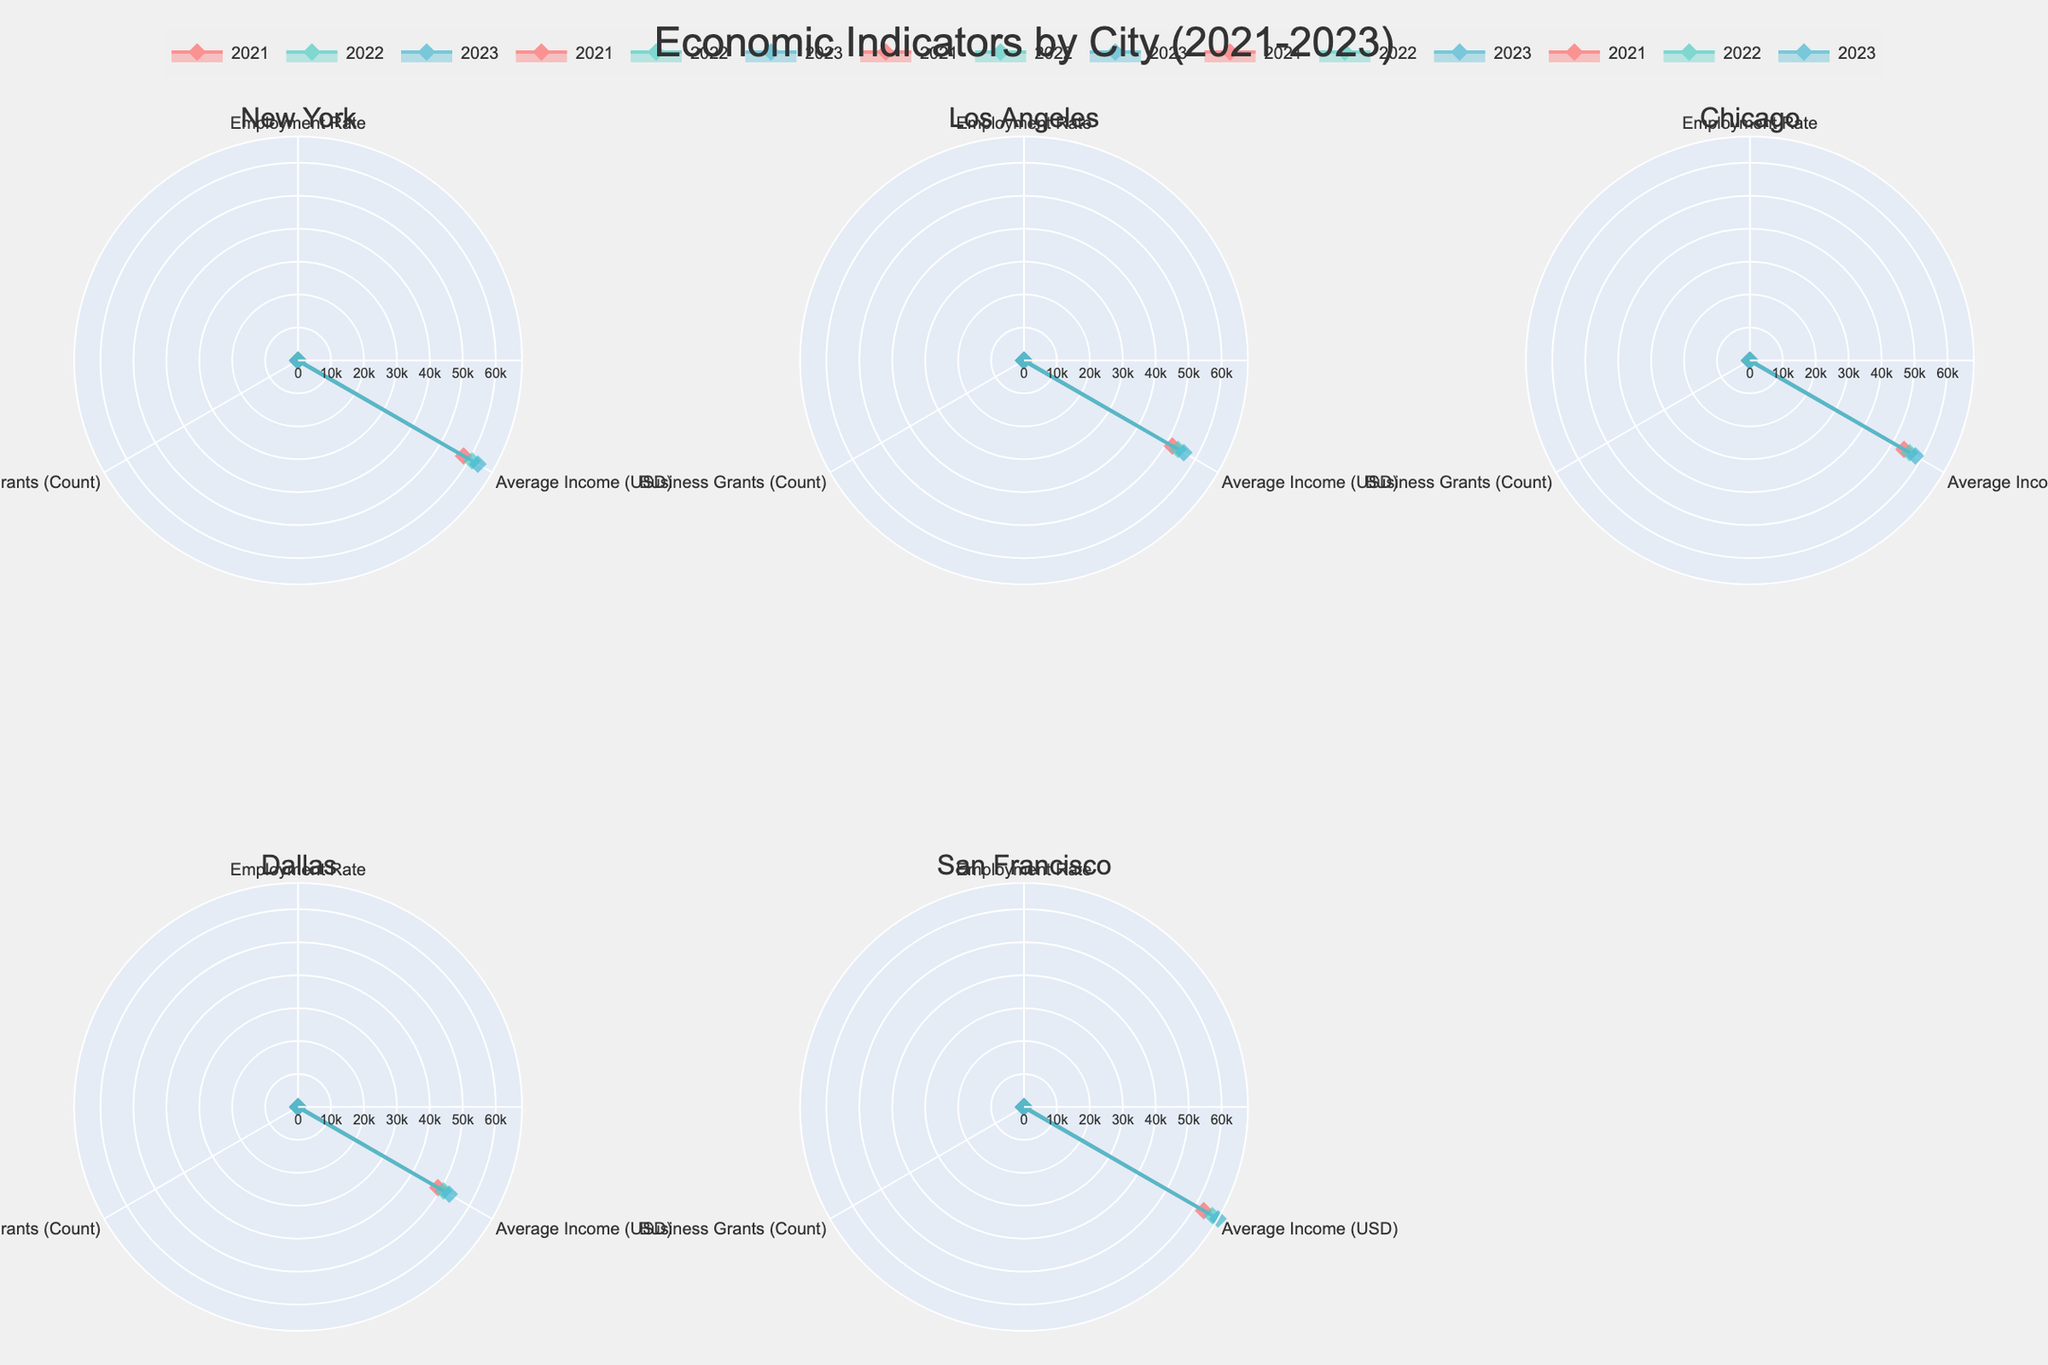What is the title of the figure? The title of the figure is displayed at the top and reads "Economic Indicators by City (2021-2023)".
Answer: Economic Indicators by City (2021-2023) Which city has the highest average income in 2023? By observing each subplot, the radar chart for San Francisco shows the highest value for Average Income in 2023, which is $68,000.
Answer: San Francisco How did the employment rate in New York change from 2021 to 2023? In New York's subplot, the employment rate increased from 92.3 in 2021 to 94.0 in 2023.
Answer: Increased Which year had the highest count of Business Grants in Los Angeles? On the Los Angeles subplot, the Business Grants count is highest in 2023 with a value of 160.
Answer: 2023 Compare the Business Grants count in Dallas for 2021 and 2022. Which year had more? In Dallas's subplot, the Business Grants count increased from 90 in 2021 to 110 in 2022, so 2022 had more.
Answer: 2022 How do the average incomes in Chicago and Dallas in 2023 compare? From the respective subplots for Chicago and Dallas, Chicago's average income in 2023 is $58,000 while Dallas's is $53,000. Chicago has a higher average income.
Answer: Chicago Which city shows the most consistent trend in employment rates from 2021 to 2023? Consistency can be seen by the uniform growth lines in each city's subplot; Los Angeles shows minimal variation with employment rates slightly rising from 90.5 in 2021 to 91.8 in 2023.
Answer: Los Angeles What is the average number of Business Grants in San Francisco over the three years? Adding the Business Grants for San Francisco (140 for 2021, 160 for 2022, and 190 for 2023), and then dividing by 3: (140 + 160 + 190) / 3 = 163.33.
Answer: 163.33 Identify the city with the lowest employment rate in 2021. Reviewing each city's subplot, Dallas has the lowest employment rate in 2021, which is 88.0.
Answer: Dallas 